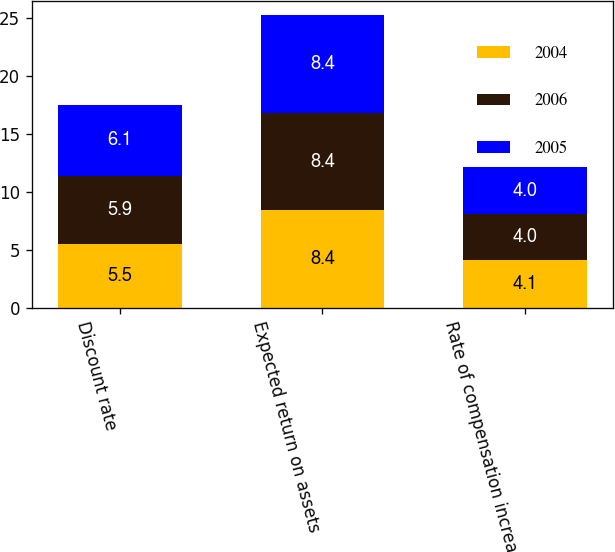Convert chart. <chart><loc_0><loc_0><loc_500><loc_500><stacked_bar_chart><ecel><fcel>Discount rate<fcel>Expected return on assets<fcel>Rate of compensation increase<nl><fcel>2004<fcel>5.5<fcel>8.4<fcel>4.1<nl><fcel>2006<fcel>5.9<fcel>8.4<fcel>4<nl><fcel>2005<fcel>6.1<fcel>8.4<fcel>4<nl></chart> 